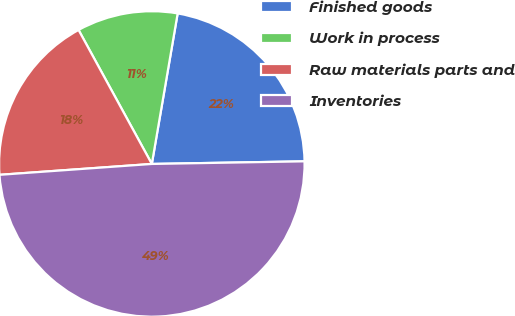Convert chart. <chart><loc_0><loc_0><loc_500><loc_500><pie_chart><fcel>Finished goods<fcel>Work in process<fcel>Raw materials parts and<fcel>Inventories<nl><fcel>22.02%<fcel>10.67%<fcel>18.17%<fcel>49.14%<nl></chart> 